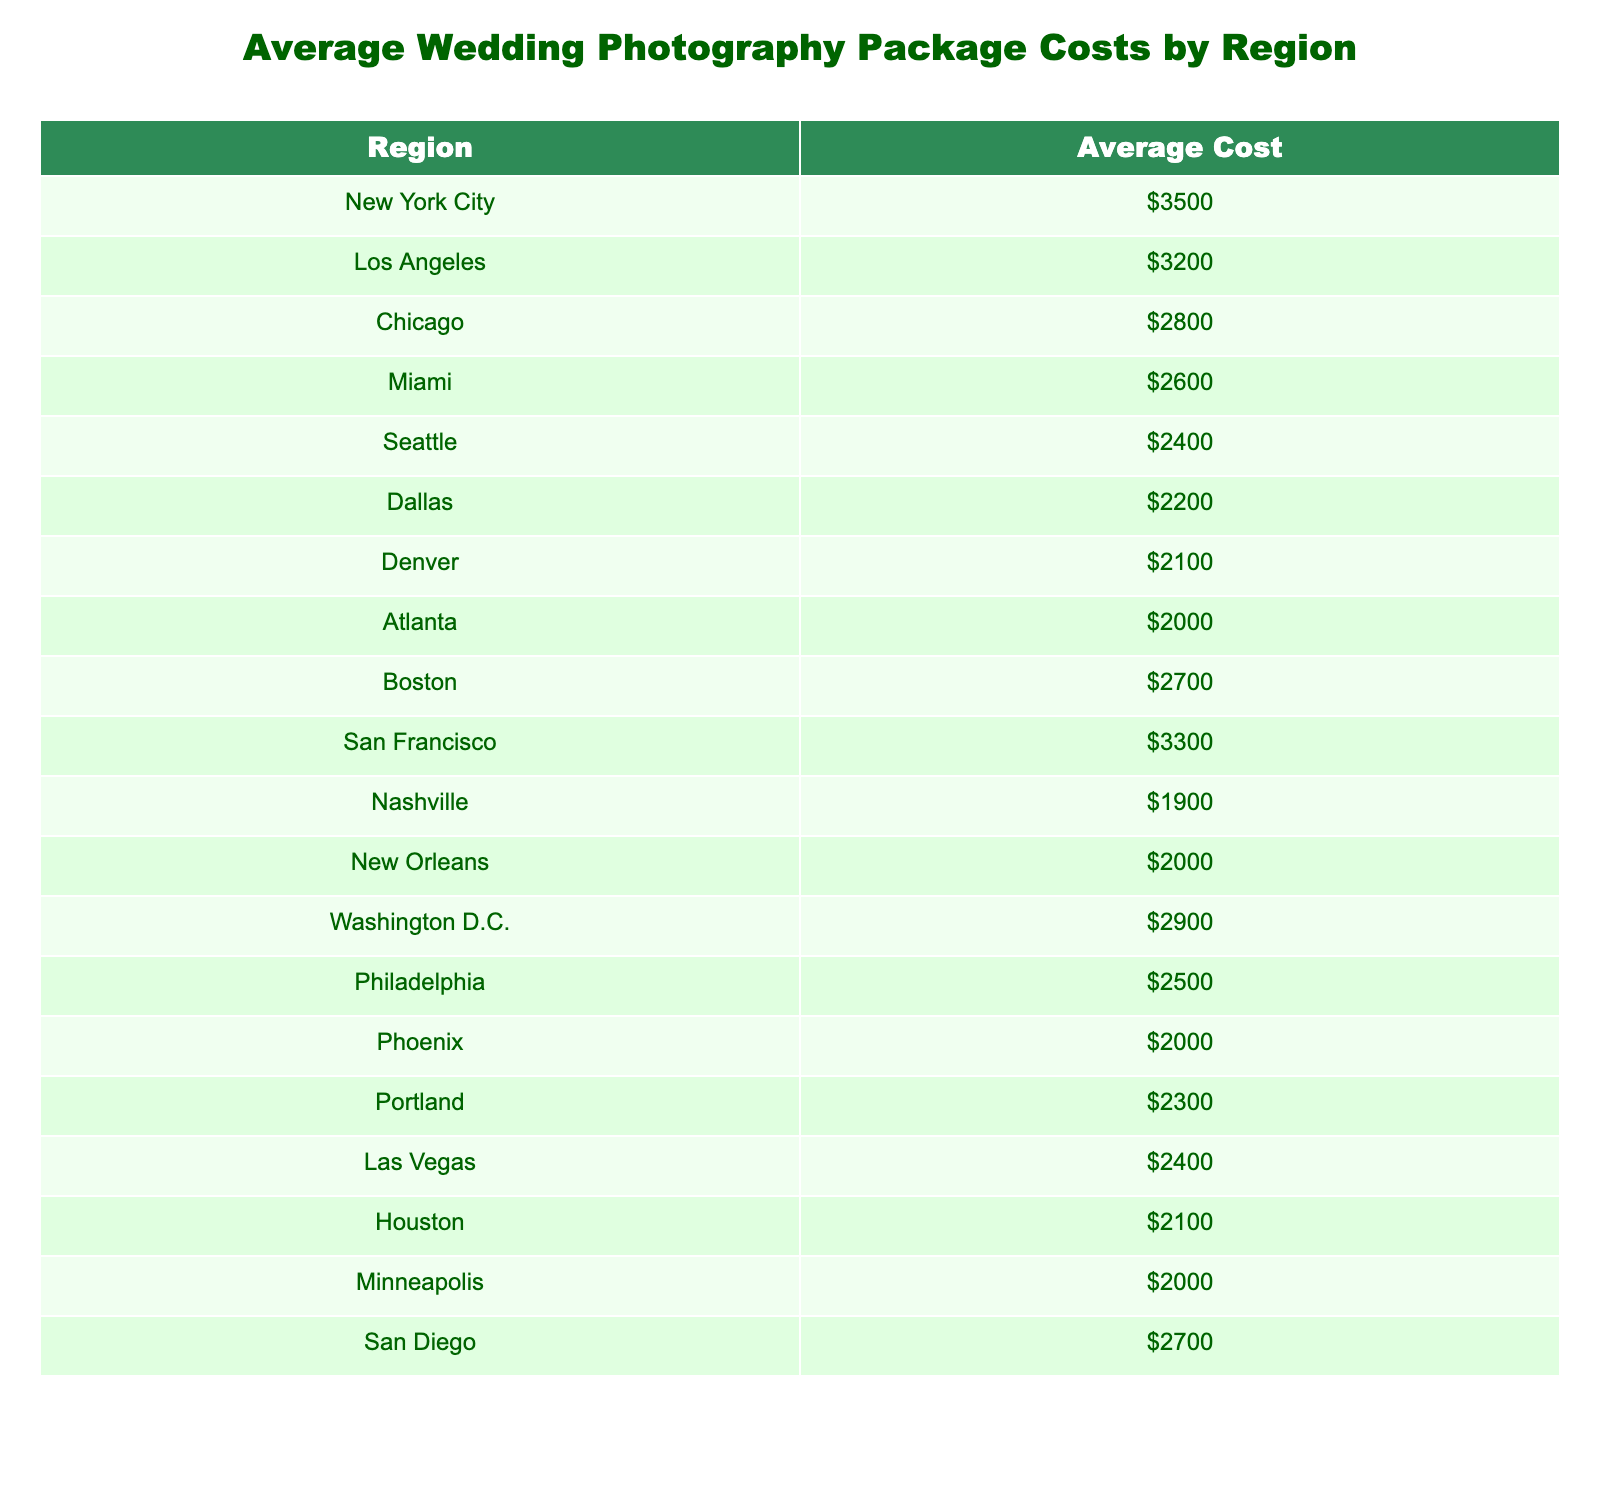What's the average cost of wedding photography in New York City? The table shows the average cost specifically listed for New York City as $3500.
Answer: $3500 Which region has the lowest average cost for wedding photography? Looking through the table, Nashville has the lowest average cost at $1900.
Answer: Nashville What is the average cost of wedding photography in San Francisco compared to Seattle? The average cost for San Francisco is $3300 and for Seattle, it's $2400. The difference is $3300 - $2400 = $900, indicating that San Francisco is more expensive.
Answer: $900 Is the average cost in Washington D.C. higher than in Philadelphia? The average cost in Washington D.C. is $2900, while in Philadelphia it is $2500. Since $2900 is greater than $2500, the statement is true.
Answer: Yes What is the total average cost of wedding photography for the regions listed? Adding all the average costs together: $3500 + $3200 + $2800 + $2600 + $2400 + $2200 + $2100 + $2000 + $2700 + $3300 + $1900 + $2000 + $2900 + $2500 + $2000 + $2300 + $2400 + $2100 + $2000 + $2700 = $44,900.
Answer: $44,900 What is the average cost of wedding photography across all regions? There are 20 regions in total. To find the average, divide the total cost of $44,900 by 20: $44,900 / 20 = $2245.
Answer: $2245 Which two regions combined have an average cost of wedding photography that exceeds $6000? The costs for San Francisco ($3300) and New York City ($3500) add up to $6800, which exceeds $6000.
Answer: Yes Is there a region where the average cost is exactly $2000? Upon checking, both Atlanta and Phoenix have an average cost of exactly $2000.
Answer: Yes How much more expensive is the average wedding photography package in Los Angeles compared to Dallas? The average cost in Los Angeles is $3200 and in Dallas, it is $2200. Therefore, the difference is $3200 - $2200 = $1000.
Answer: $1000 Which region has an average cost that is closer to the national average? The average calculated above is $2245. The closest value from the table is Portland at $2300, which is only $55 off.
Answer: Portland 